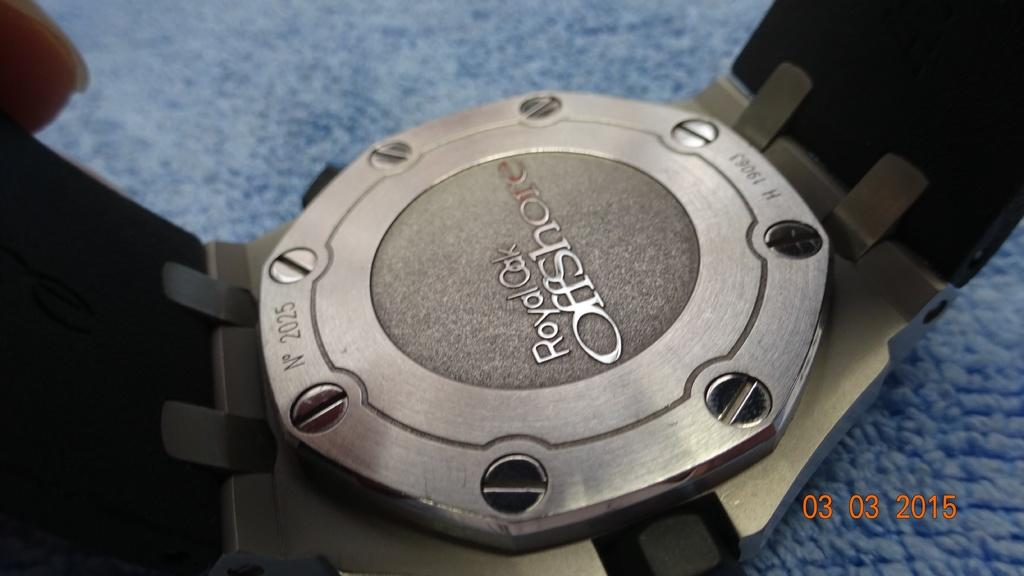<image>
Relay a brief, clear account of the picture shown. A metal plate ringed with screws bears the stamp Royal Oak Offshore. 